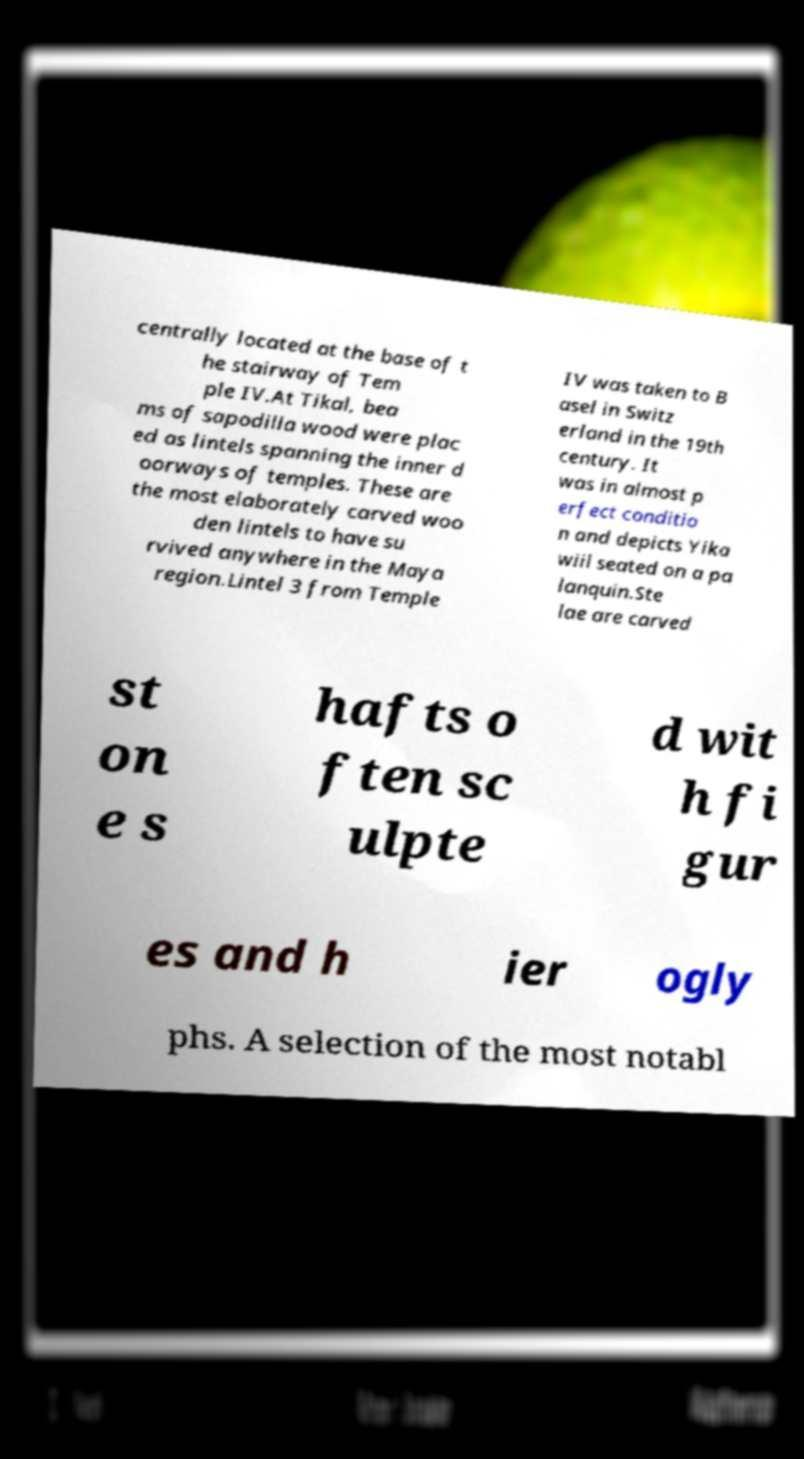Could you assist in decoding the text presented in this image and type it out clearly? centrally located at the base of t he stairway of Tem ple IV.At Tikal, bea ms of sapodilla wood were plac ed as lintels spanning the inner d oorways of temples. These are the most elaborately carved woo den lintels to have su rvived anywhere in the Maya region.Lintel 3 from Temple IV was taken to B asel in Switz erland in the 19th century. It was in almost p erfect conditio n and depicts Yika wiil seated on a pa lanquin.Ste lae are carved st on e s hafts o ften sc ulpte d wit h fi gur es and h ier ogly phs. A selection of the most notabl 